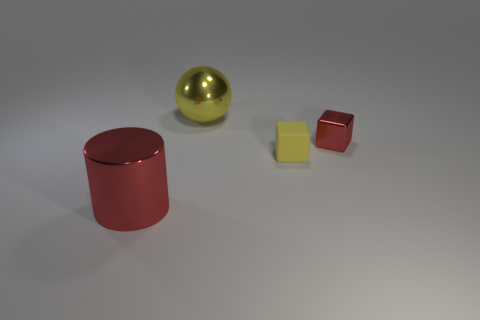Add 2 large brown shiny spheres. How many objects exist? 6 Subtract all cylinders. How many objects are left? 3 Add 2 small shiny things. How many small shiny things are left? 3 Add 2 large blue matte blocks. How many large blue matte blocks exist? 2 Subtract 0 blue balls. How many objects are left? 4 Subtract all metallic cubes. Subtract all small yellow matte blocks. How many objects are left? 2 